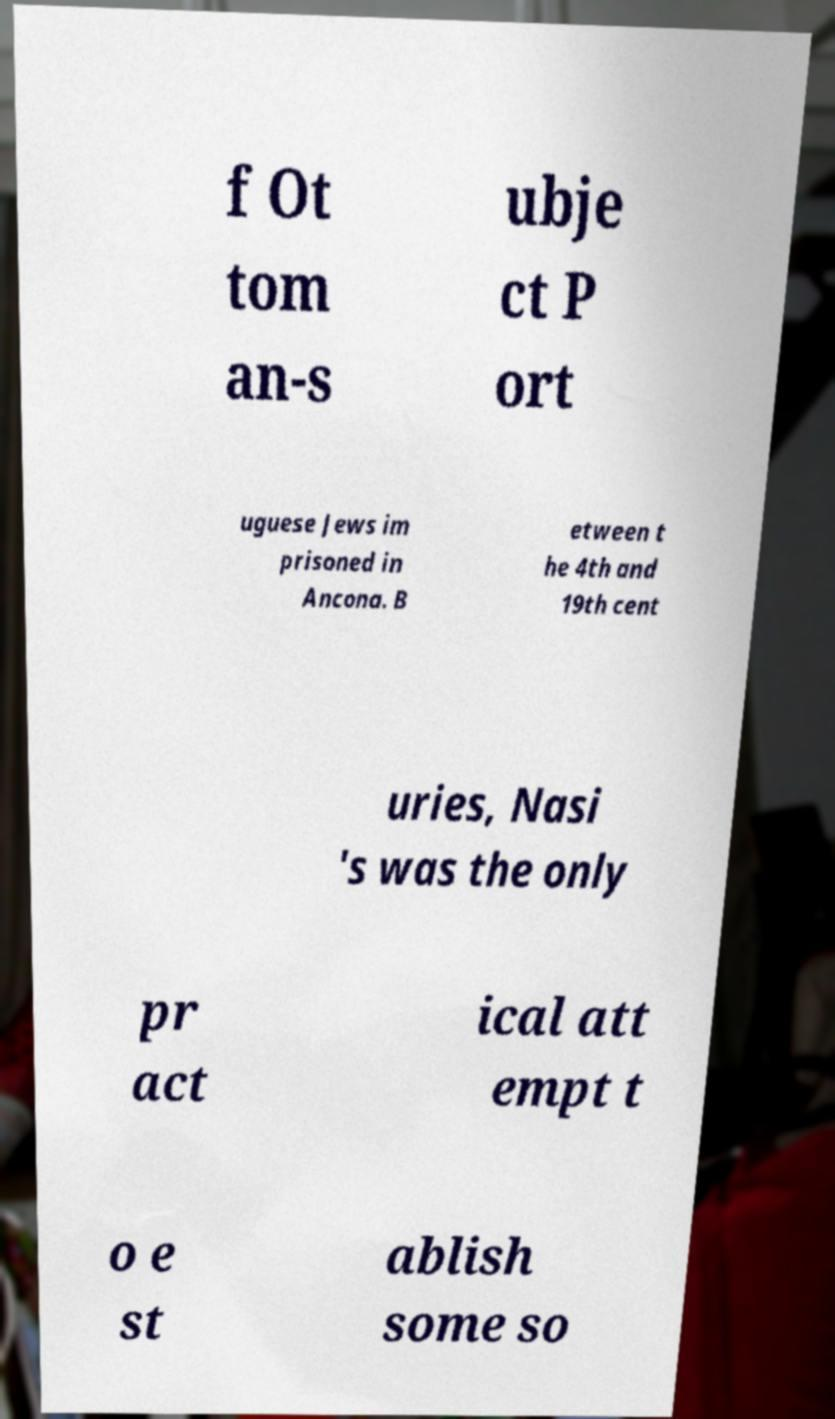Could you assist in decoding the text presented in this image and type it out clearly? f Ot tom an-s ubje ct P ort uguese Jews im prisoned in Ancona. B etween t he 4th and 19th cent uries, Nasi 's was the only pr act ical att empt t o e st ablish some so 